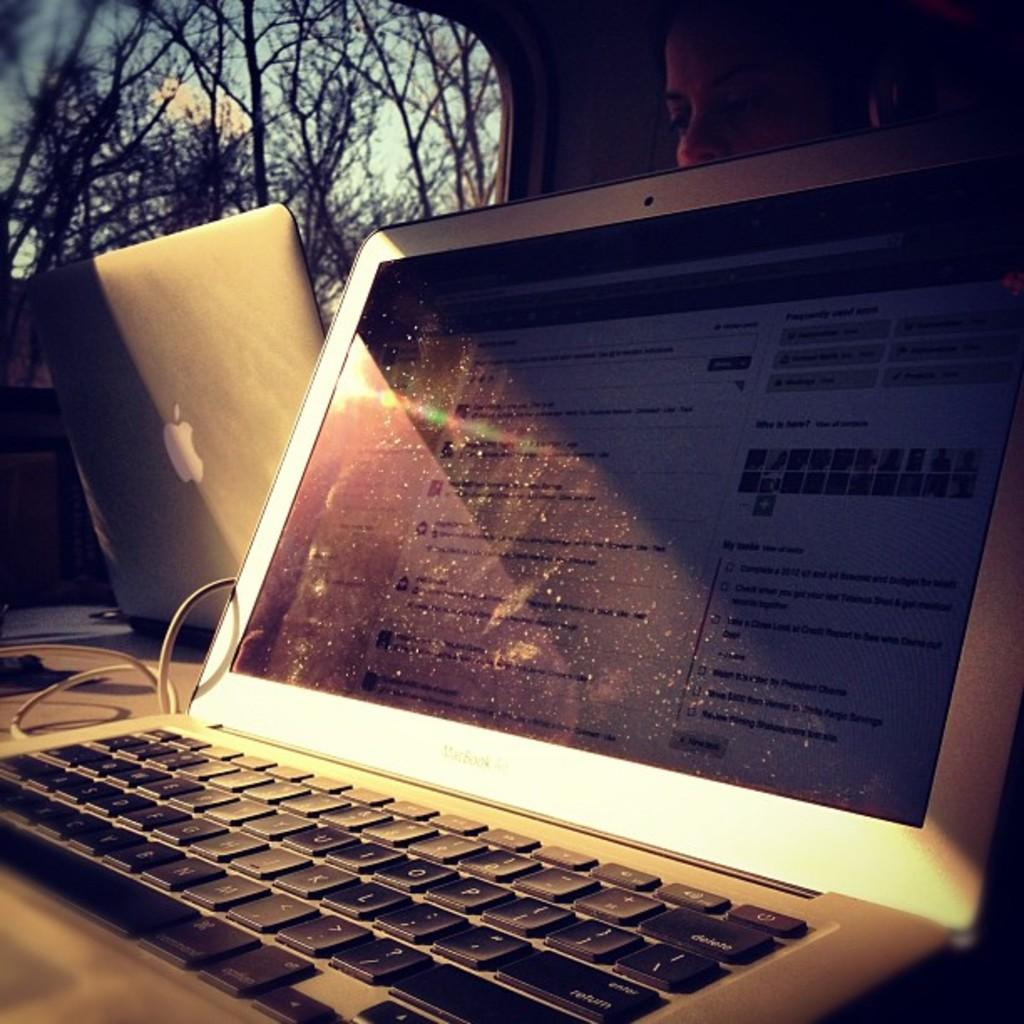What electronic device is present in the image? There is a laptop in the image. What is the person in the image doing with another laptop? The person is working on another laptop in the image. What can be seen in the background of the image? Trees are visible in the image. Is there any connection between the laptop and another object in the image? Yes, there is a wire connected to a laptop in the image. Where are the beds and lettuce located in the image? There are no beds or lettuce present in the image. 